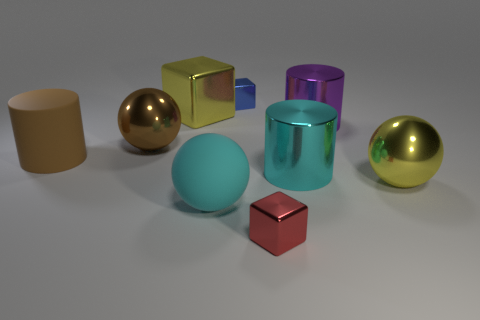There is a thing that is the same color as the big rubber cylinder; what shape is it?
Your answer should be compact. Sphere. What is the size of the cylinder that is the same color as the matte ball?
Make the answer very short. Large. How many things are either small metal objects that are to the left of the small red object or objects to the right of the red metal thing?
Ensure brevity in your answer.  4. Are there more big cyan matte objects than large rubber objects?
Your answer should be very brief. No. What color is the rubber thing that is right of the brown ball?
Make the answer very short. Cyan. Does the big purple metallic thing have the same shape as the large brown metal thing?
Provide a succinct answer. No. There is a cylinder that is both in front of the large purple metal cylinder and right of the large brown cylinder; what is its color?
Ensure brevity in your answer.  Cyan. There is a sphere that is behind the large cyan metallic object; is it the same size as the brown matte object that is to the left of the red metallic block?
Make the answer very short. Yes. How many things are large balls that are to the left of the cyan cylinder or big cyan shiny cylinders?
Your response must be concise. 3. What is the purple cylinder made of?
Offer a terse response. Metal. 